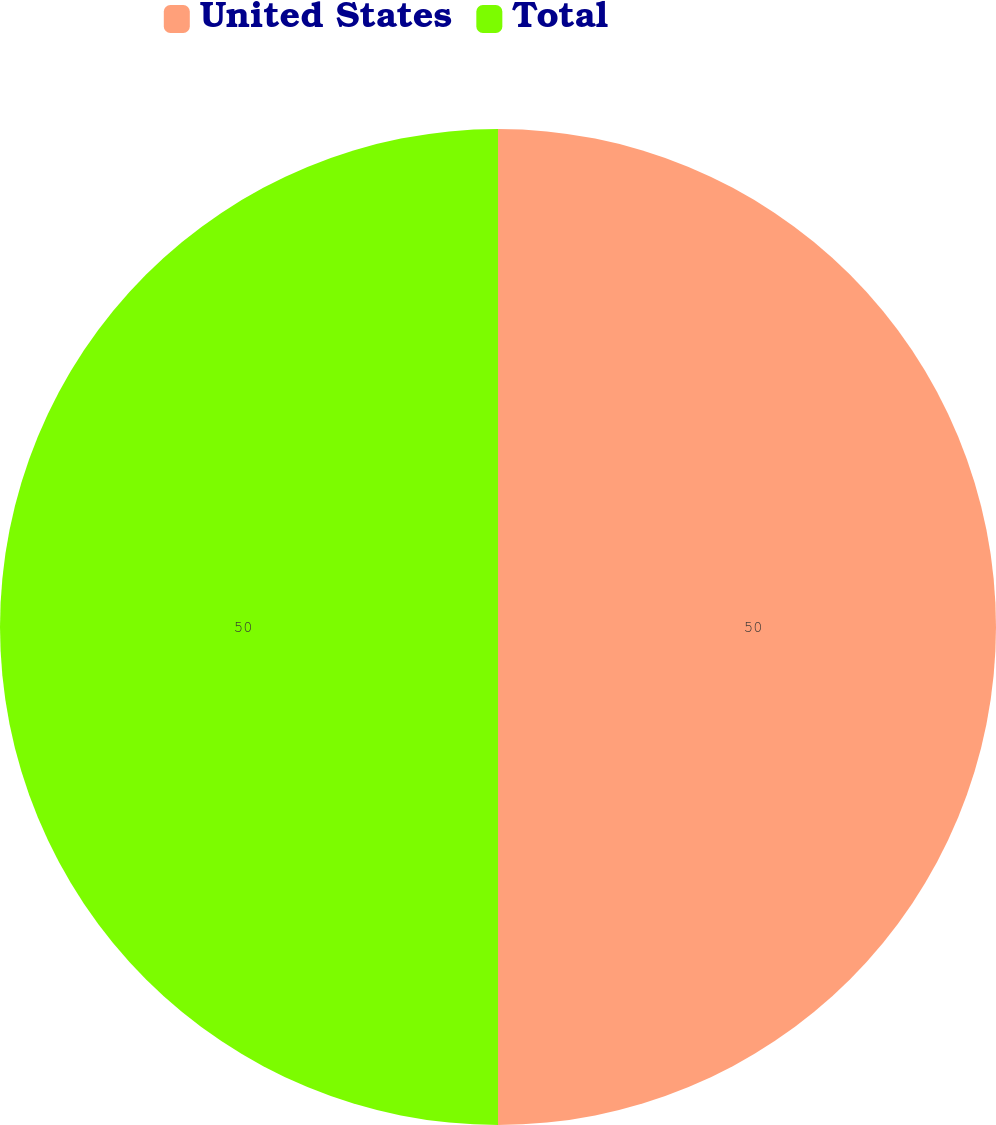Convert chart to OTSL. <chart><loc_0><loc_0><loc_500><loc_500><pie_chart><fcel>United States<fcel>Total<nl><fcel>50.0%<fcel>50.0%<nl></chart> 